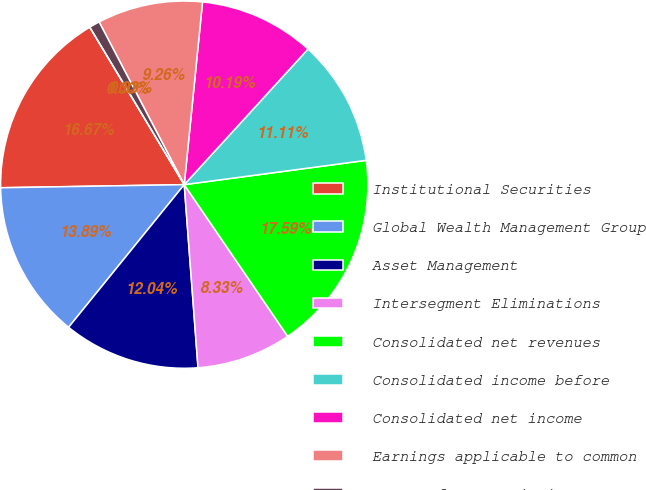Convert chart. <chart><loc_0><loc_0><loc_500><loc_500><pie_chart><fcel>Institutional Securities<fcel>Global Wealth Management Group<fcel>Asset Management<fcel>Intersegment Eliminations<fcel>Consolidated net revenues<fcel>Consolidated income before<fcel>Consolidated net income<fcel>Earnings applicable to common<fcel>Income from continuing<fcel>Gain on discontinued<nl><fcel>16.67%<fcel>13.89%<fcel>12.04%<fcel>8.33%<fcel>17.59%<fcel>11.11%<fcel>10.19%<fcel>9.26%<fcel>0.93%<fcel>0.0%<nl></chart> 